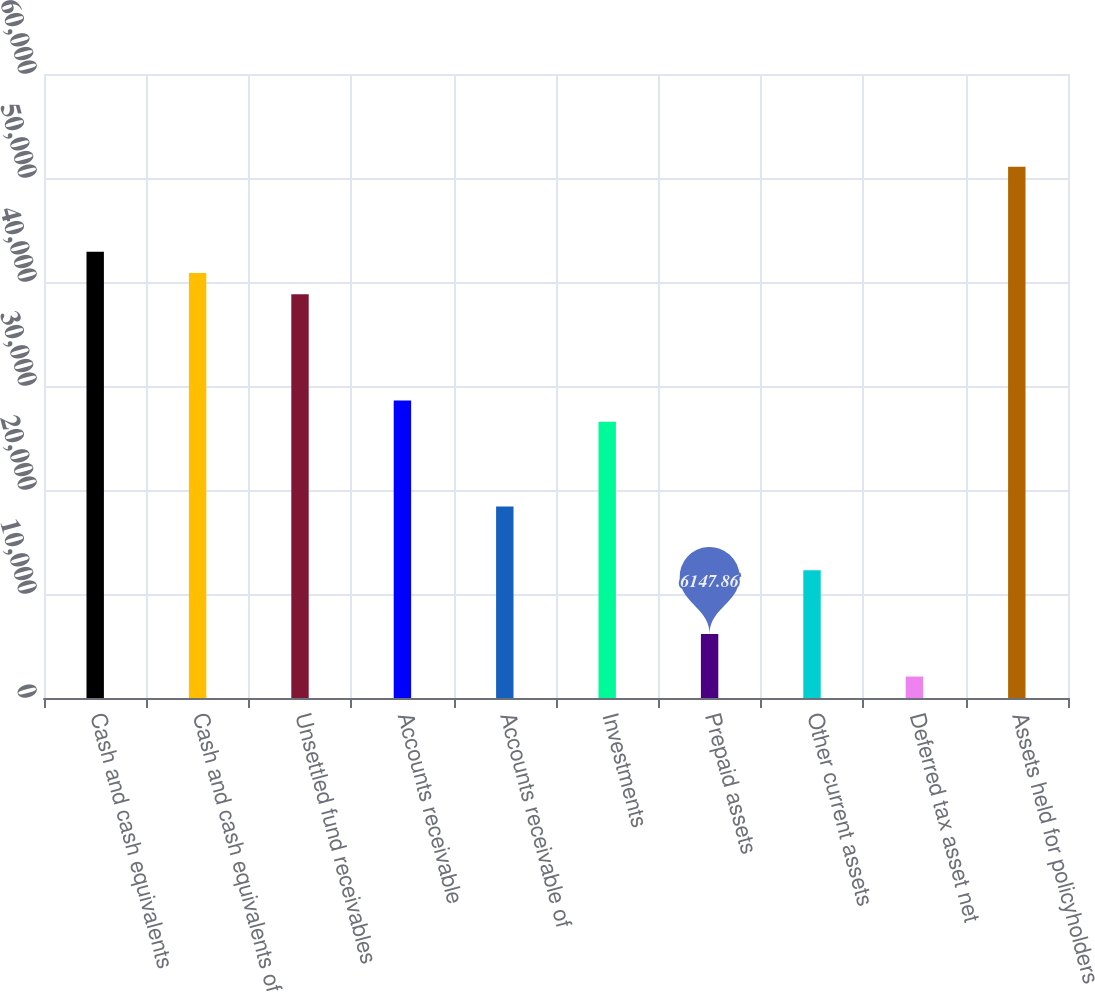<chart> <loc_0><loc_0><loc_500><loc_500><bar_chart><fcel>Cash and cash equivalents<fcel>Cash and cash equivalents of<fcel>Unsettled fund receivables<fcel>Accounts receivable<fcel>Accounts receivable of<fcel>Investments<fcel>Prepaid assets<fcel>Other current assets<fcel>Deferred tax asset net<fcel>Assets held for policyholders<nl><fcel>42909.6<fcel>40867.3<fcel>38825<fcel>28613.4<fcel>18401.8<fcel>26571.1<fcel>6147.86<fcel>12274.8<fcel>2063.22<fcel>51078.9<nl></chart> 